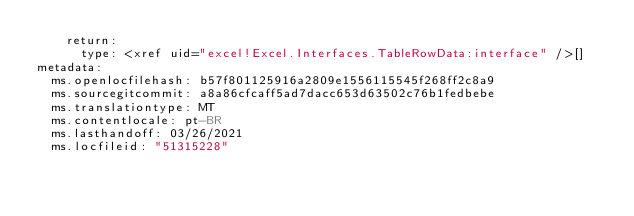<code> <loc_0><loc_0><loc_500><loc_500><_YAML_>    return:
      type: <xref uid="excel!Excel.Interfaces.TableRowData:interface" />[]
metadata:
  ms.openlocfilehash: b57f801125916a2809e1556115545f268ff2c8a9
  ms.sourcegitcommit: a8a86cfcaff5ad7dacc653d63502c76b1fedbebe
  ms.translationtype: MT
  ms.contentlocale: pt-BR
  ms.lasthandoff: 03/26/2021
  ms.locfileid: "51315228"
</code> 